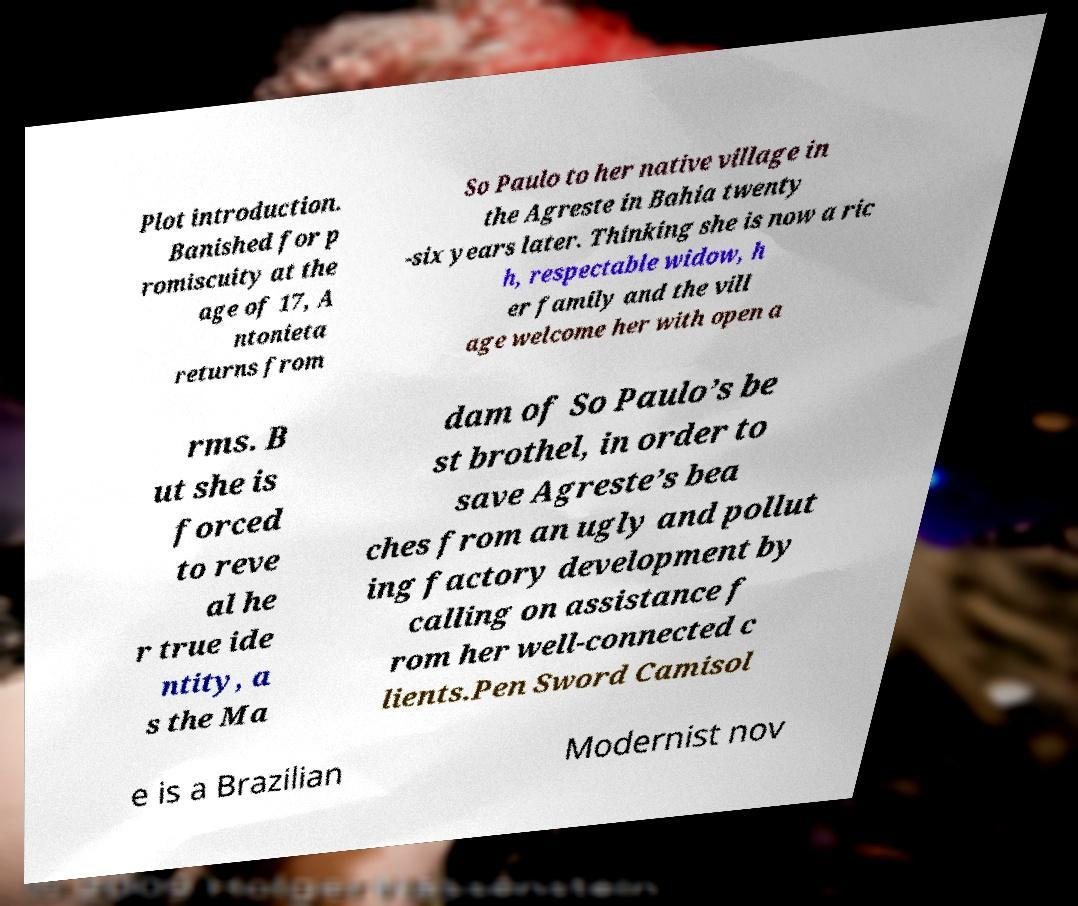Could you extract and type out the text from this image? Plot introduction. Banished for p romiscuity at the age of 17, A ntonieta returns from So Paulo to her native village in the Agreste in Bahia twenty -six years later. Thinking she is now a ric h, respectable widow, h er family and the vill age welcome her with open a rms. B ut she is forced to reve al he r true ide ntity, a s the Ma dam of So Paulo’s be st brothel, in order to save Agreste’s bea ches from an ugly and pollut ing factory development by calling on assistance f rom her well-connected c lients.Pen Sword Camisol e is a Brazilian Modernist nov 